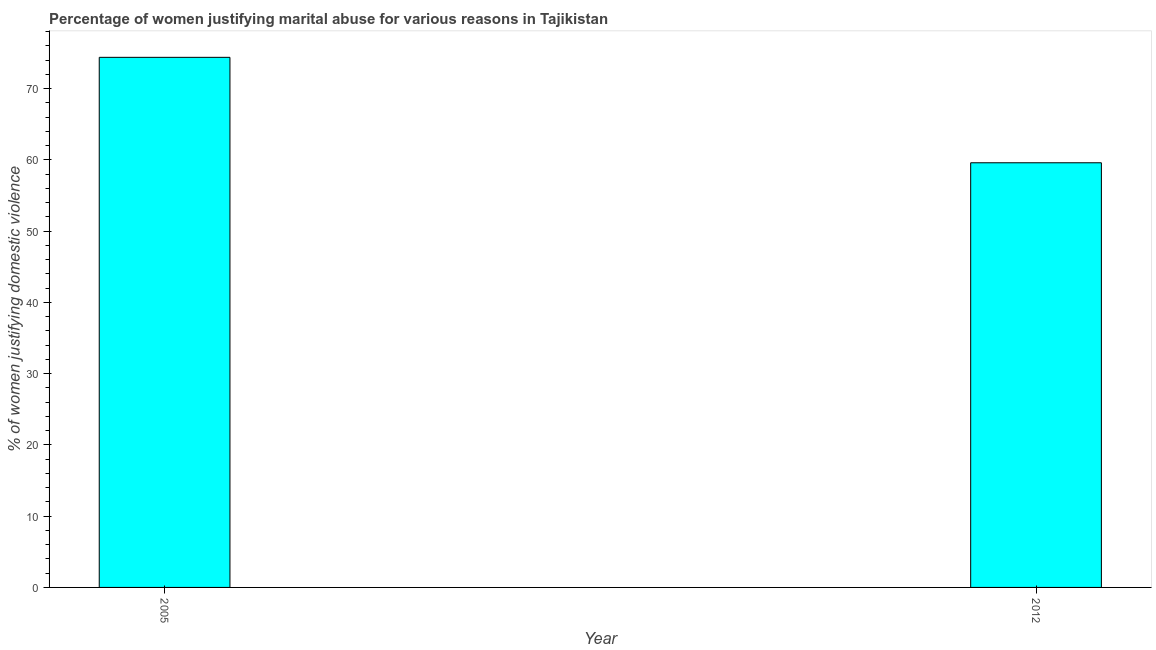Does the graph contain any zero values?
Offer a very short reply. No. Does the graph contain grids?
Your answer should be very brief. No. What is the title of the graph?
Offer a terse response. Percentage of women justifying marital abuse for various reasons in Tajikistan. What is the label or title of the Y-axis?
Your answer should be very brief. % of women justifying domestic violence. What is the percentage of women justifying marital abuse in 2005?
Offer a very short reply. 74.4. Across all years, what is the maximum percentage of women justifying marital abuse?
Your answer should be very brief. 74.4. Across all years, what is the minimum percentage of women justifying marital abuse?
Make the answer very short. 59.6. In which year was the percentage of women justifying marital abuse maximum?
Give a very brief answer. 2005. In which year was the percentage of women justifying marital abuse minimum?
Give a very brief answer. 2012. What is the sum of the percentage of women justifying marital abuse?
Offer a terse response. 134. What is the difference between the percentage of women justifying marital abuse in 2005 and 2012?
Provide a succinct answer. 14.8. What is the average percentage of women justifying marital abuse per year?
Your response must be concise. 67. In how many years, is the percentage of women justifying marital abuse greater than 20 %?
Offer a terse response. 2. Do a majority of the years between 2005 and 2012 (inclusive) have percentage of women justifying marital abuse greater than 8 %?
Make the answer very short. Yes. What is the ratio of the percentage of women justifying marital abuse in 2005 to that in 2012?
Give a very brief answer. 1.25. How many bars are there?
Your answer should be very brief. 2. What is the difference between two consecutive major ticks on the Y-axis?
Your answer should be compact. 10. What is the % of women justifying domestic violence of 2005?
Make the answer very short. 74.4. What is the % of women justifying domestic violence in 2012?
Offer a very short reply. 59.6. What is the difference between the % of women justifying domestic violence in 2005 and 2012?
Offer a terse response. 14.8. What is the ratio of the % of women justifying domestic violence in 2005 to that in 2012?
Make the answer very short. 1.25. 